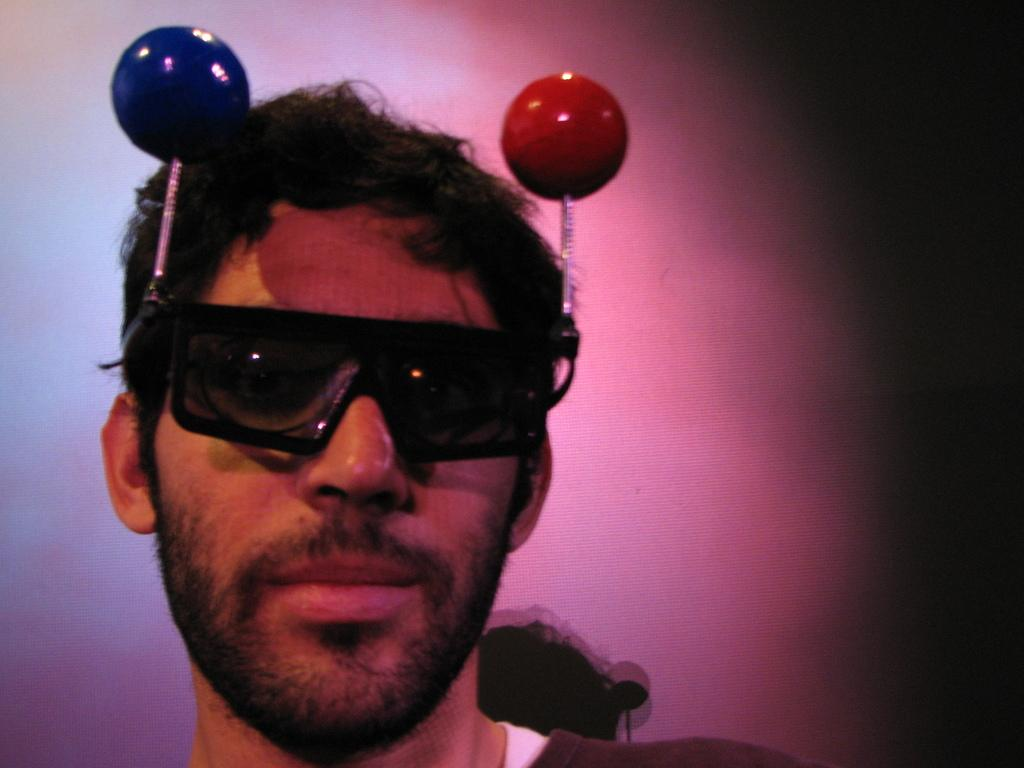What is present in the image that serves as a barrier or divider? There is a wall in the image. What is the person in the image wearing on their face? The person is wearing goggles in the image. What type of seed is being planted by the person in the image? There is no seed or planting activity present in the image. What type of drum is being played by the person in the image? There is no drum or musical activity present in the image. What type of boat is being used by the person in the image? There is no boat or water-related activity present in the image. 